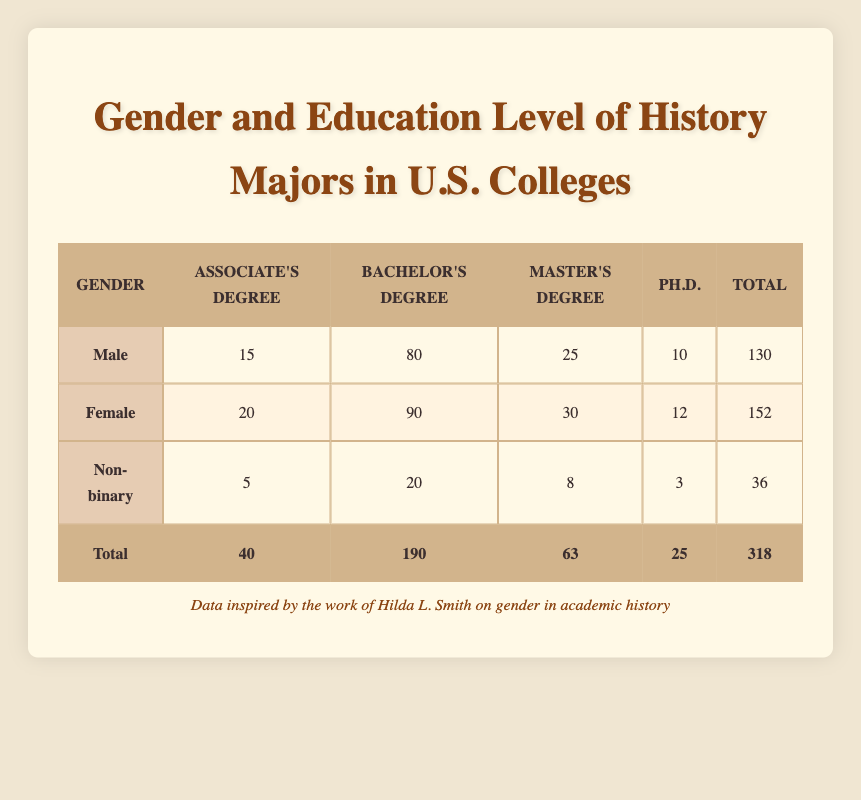What is the total number of Male History Majors? To find the total number of Male History Majors, we look at the last column in the Male row where the counts are listed. The total count for Male is given as 130.
Answer: 130 What is the count of Female History Majors with a Master's Degree? In the table, under the Female row, we check the Master's Degree column, where the count is listed as 30.
Answer: 30 Is the number of Male History Majors with a Ph.D. greater than the number of Non-binary Majors with a Ph.D.? The count of Male History Majors with a Ph.D. is 10, while the count of Non-binary Majors with a Ph.D. is 3. Since 10 is greater than 3, the statement is true.
Answer: Yes What is the average count of Associate's Degrees among all genders? We add the counts of Associate's Degrees from all three genders: 15 (Male) + 20 (Female) + 5 (Non-binary) = 40. Since there are 3 groups, we divide 40 by 3 to get the average, which is approximately 13.33.
Answer: 13.33 How many more Female History Majors graduated with a Bachelor’s Degree compared to Non-binary History Majors? From the table, Female Majors with a Bachelor's Degree count is 90, and Non-binary Majors with a Bachelor's Degree count is 20. To find the difference, we calculate 90 - 20, which equals 70.
Answer: 70 What is the total number of Non-binary History Majors? We find the total count for Non-binary History Majors in the last column of the Non-binary row, which is shown as 36.
Answer: 36 Are there more Female History Majors than Male History Majors with a Master's Degree? The count of Female History Majors with a Master's Degree is 30, while that of Male Majors with a Master's Degree is 25. Since 30 is greater than 25, the statement is true.
Answer: Yes What percentage of total History Majors are Female? The total number of Female History Majors is 152, and the grand total of History Majors is 318. To find the percentage, we calculate (152 / 318) * 100 which is approximately 47.77%.
Answer: 47.77% 